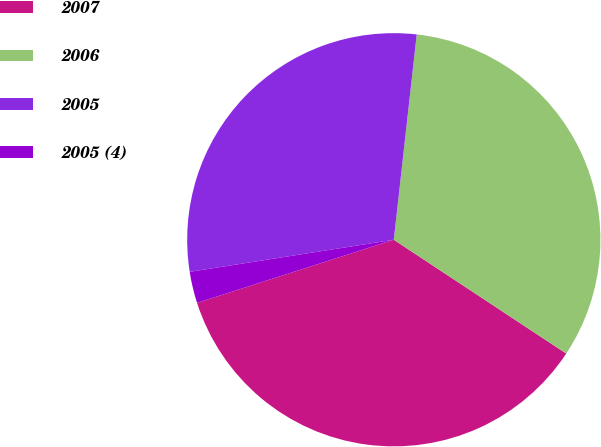Convert chart to OTSL. <chart><loc_0><loc_0><loc_500><loc_500><pie_chart><fcel>2007<fcel>2006<fcel>2005<fcel>2005 (4)<nl><fcel>35.77%<fcel>32.51%<fcel>29.25%<fcel>2.46%<nl></chart> 